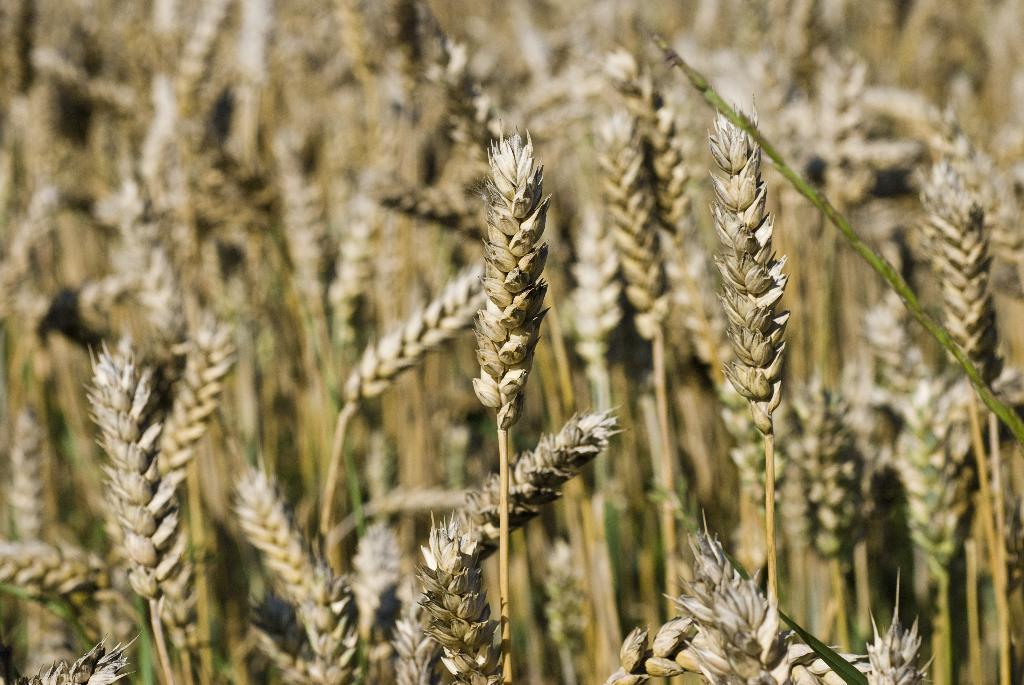Describe this image in one or two sentences. In this picture I can see wheat plants, and there is blur background. 